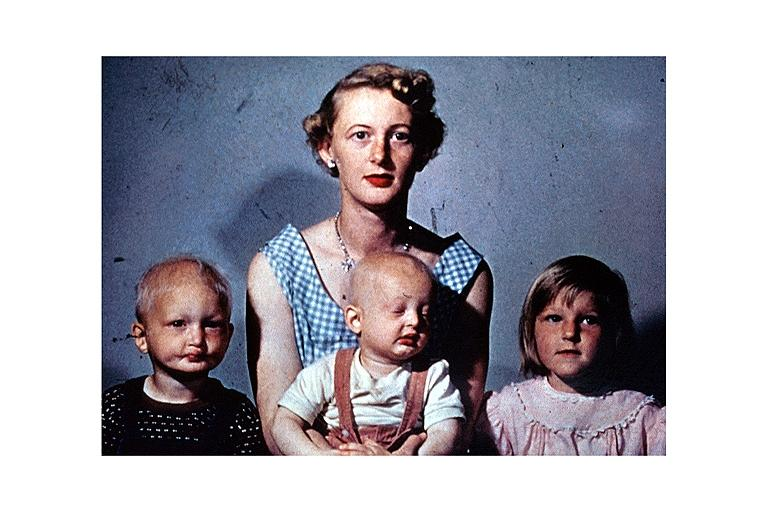does no tissue recognizable as ovary show anhidrotic ectodermal dysplasia?
Answer the question using a single word or phrase. No 